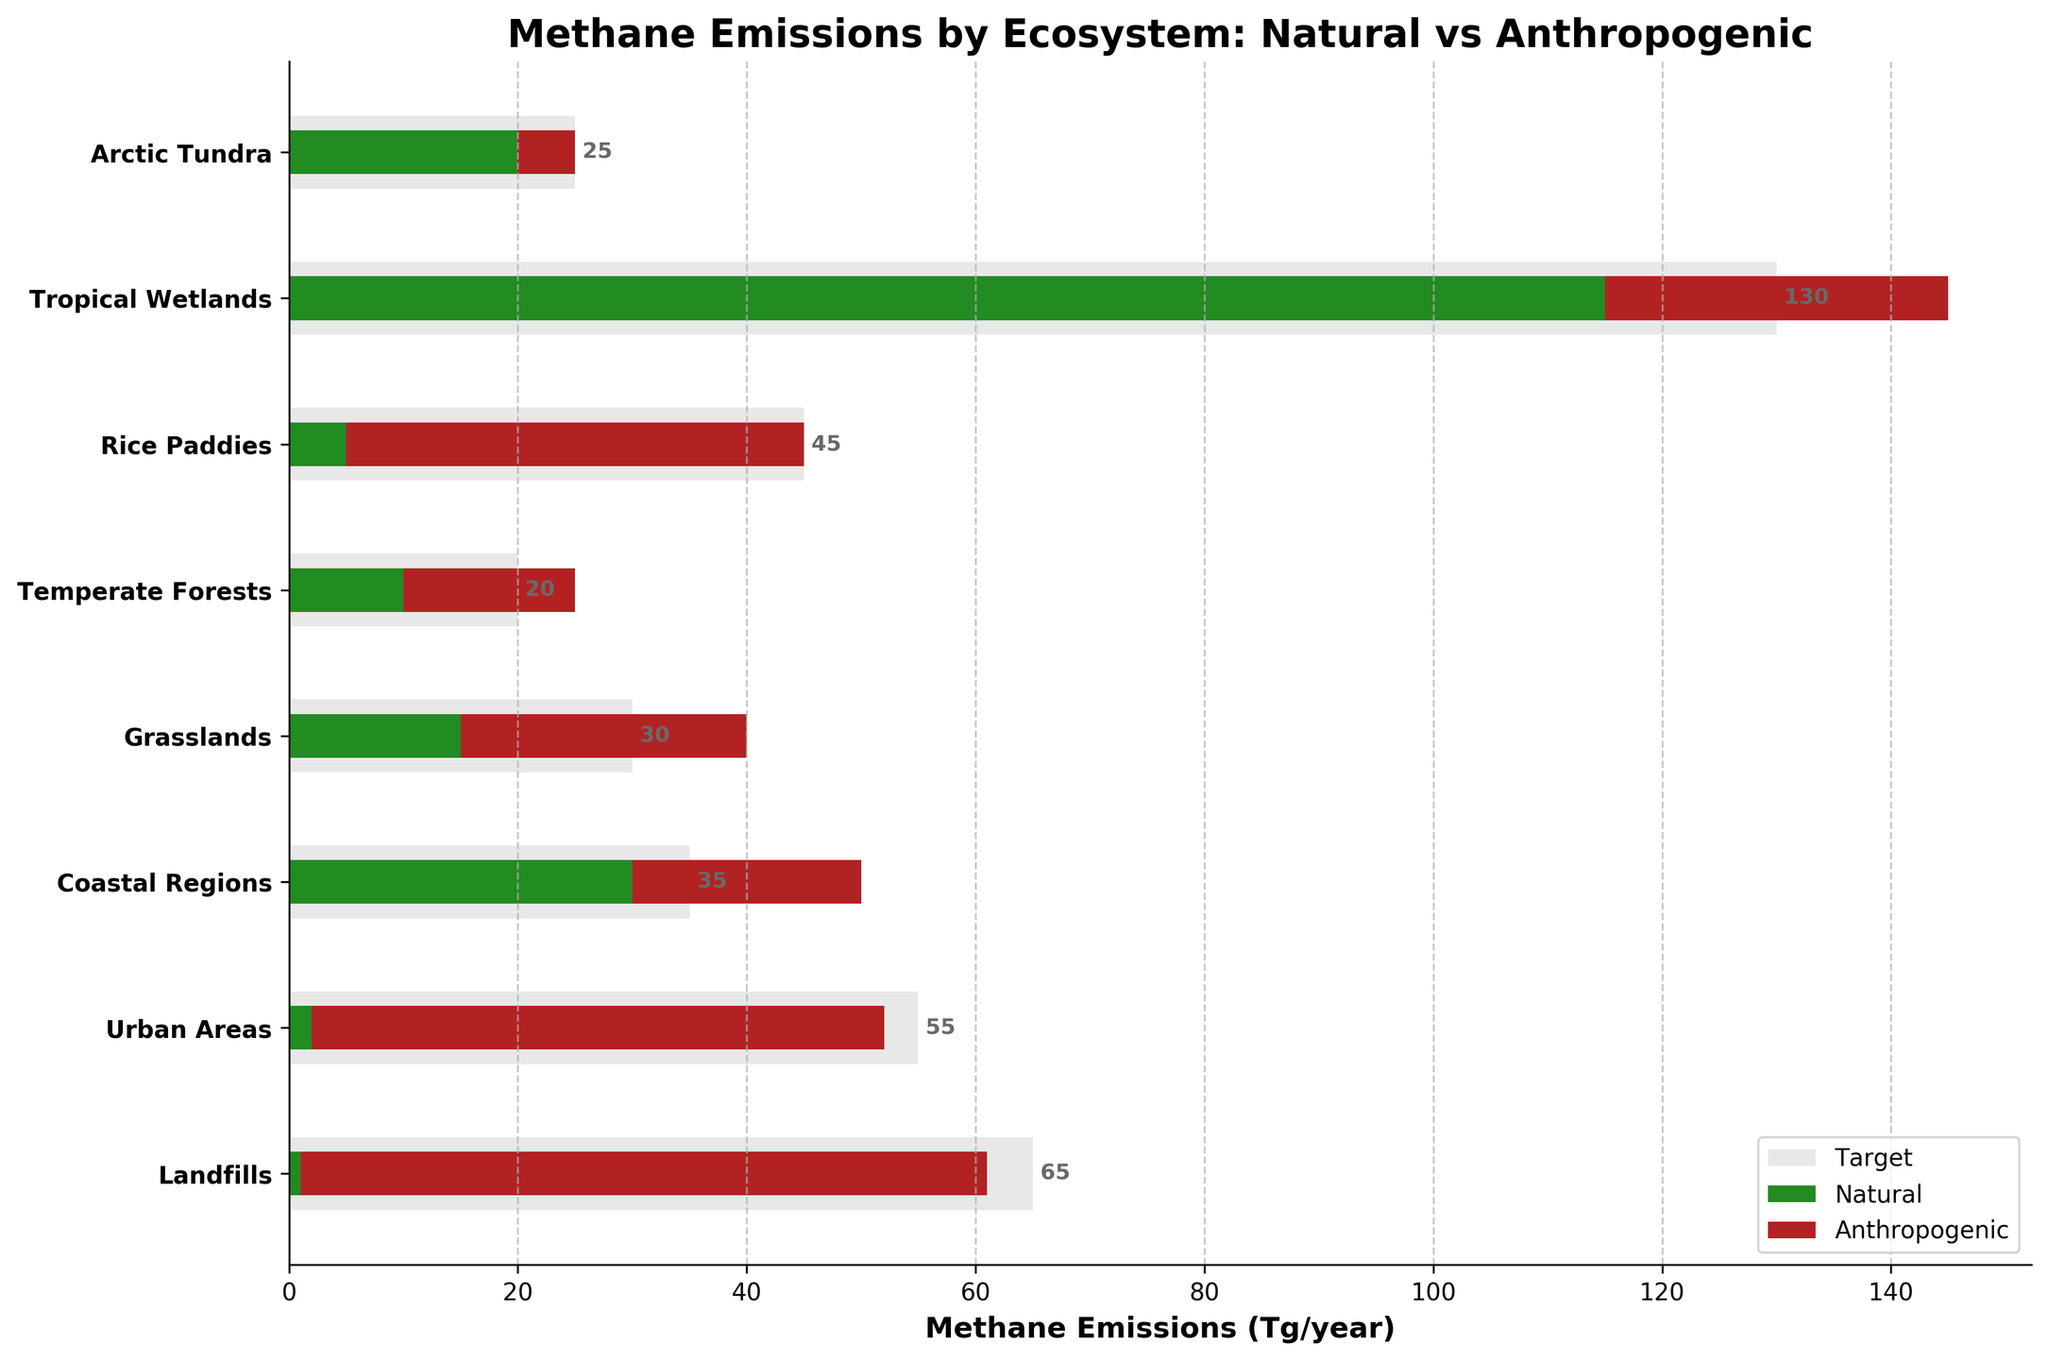How many ecosystems are displayed on the chart? Count the number of ecosystems listed on the y-axis of the bullet chart.
Answer: 8 What is the target methane emissions for Arctic Tundra? Look at the light grey bar for Arctic Tundra and read its value.
Answer: 25 Tg/year Is anthropogenic methane emission higher than natural methane emission in Temperate Forests? Compare the lengths of the red (anthropogenic) and green (natural) bars for Temperate Forests.
Answer: Yes Which ecosystem has the highest total methane emissions (natural plus anthropogenic)? Add the values of natural and anthropogenic methane emissions for each ecosystem, then compare the sums.
Answer: Tropical Wetlands How much anthropogenic methane is emitted by landfills? Identify the red bar corresponding to Landfills and read its value.
Answer: 60 Tg/year What is the difference between the target and the current total methane emissions for Rice Paddies? Subtract the combined length of the natural and anthropogenic bars from the target bar for Rice Paddies.
Answer: 0 Tg/year Where is the highest discrepancy between actual total emissions and the target values observed? Calculate the difference between target and the sum of actual emissions for each ecosystem, then identify the largest discrepancy.
Answer: Landfills How do the natural methane emissions in Grasslands compare to those in Temperate Forests? Compare the lengths of the green bars for Grasslands and Temperate Forests.
Answer: Higher in Grasslands Are there more natural or anthropogenic sources contributing to the total methane emissions in Coastal Regions? Compare the green and red bars for Coastal Regions.
Answer: Natural What is the combined methane emissions for Urban Areas? Sum the length of the green (natural) and red (anthropogenic) bars for Urban Areas.
Answer: 52 Tg/year 